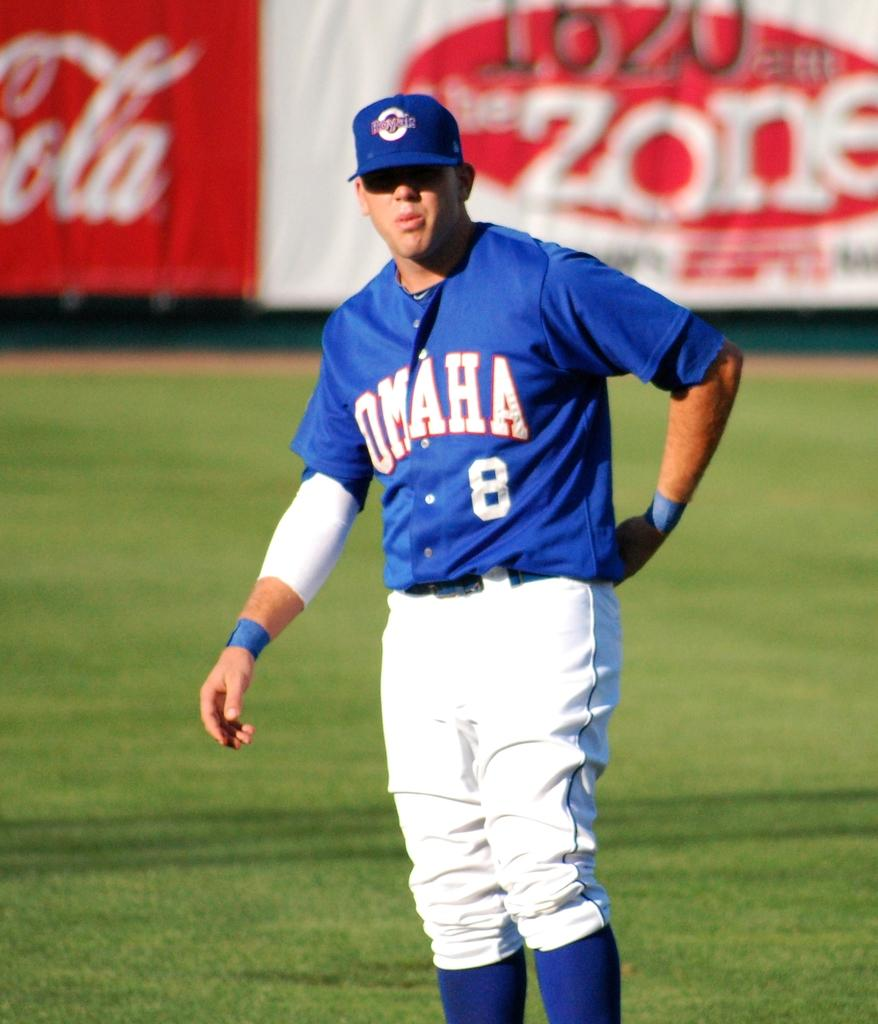<image>
Write a terse but informative summary of the picture. Number 8 Omaha baseball players stands on the field wearing a blue cap, blue jersey, blue socks and white pants. 